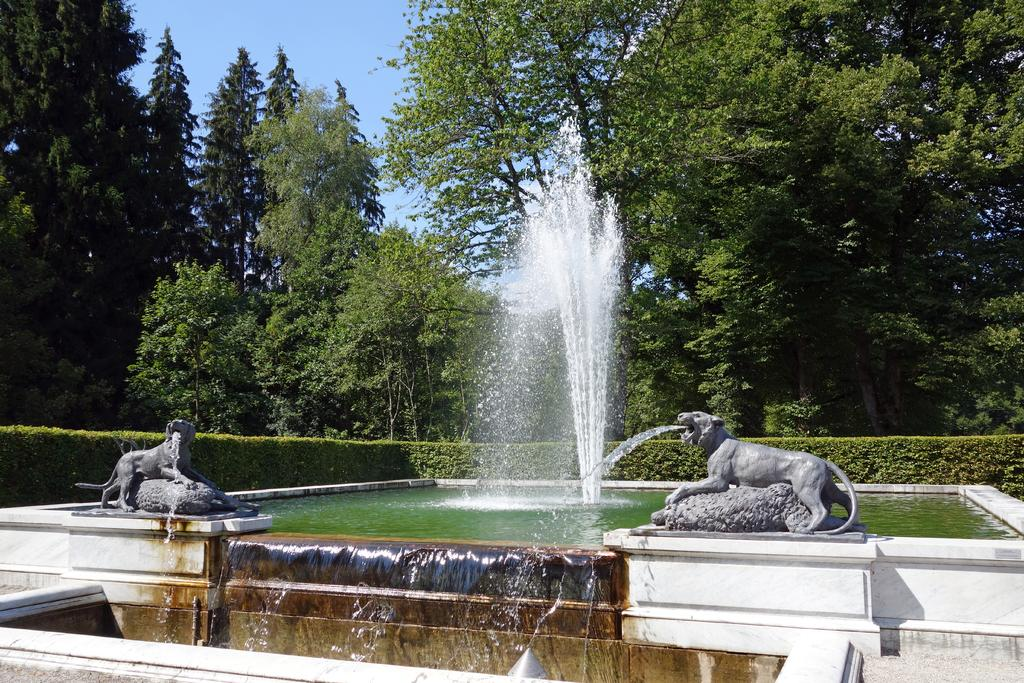What type of objects are depicted as statues in the image? There are statues of animals in the image. What is the primary architectural feature in the image? There is a wall in the image. What is the water feature in the image? There is a water fountain in the image. What type of vegetation can be seen in the background of the image? There are plants and trees in the background of the image. What part of the natural environment is visible in the background of the image? The sky is visible in the background of the image. What type of oil can be seen dripping from the statues in the image? There is no oil present in the image; it features statues of animals, a wall, a water fountain, plants, trees, and the sky. What room is the water fountain located in the image? The image does not specify a room, as it appears to be an outdoor setting with a wall, statues, a water fountain, plants, trees, and the sky. 